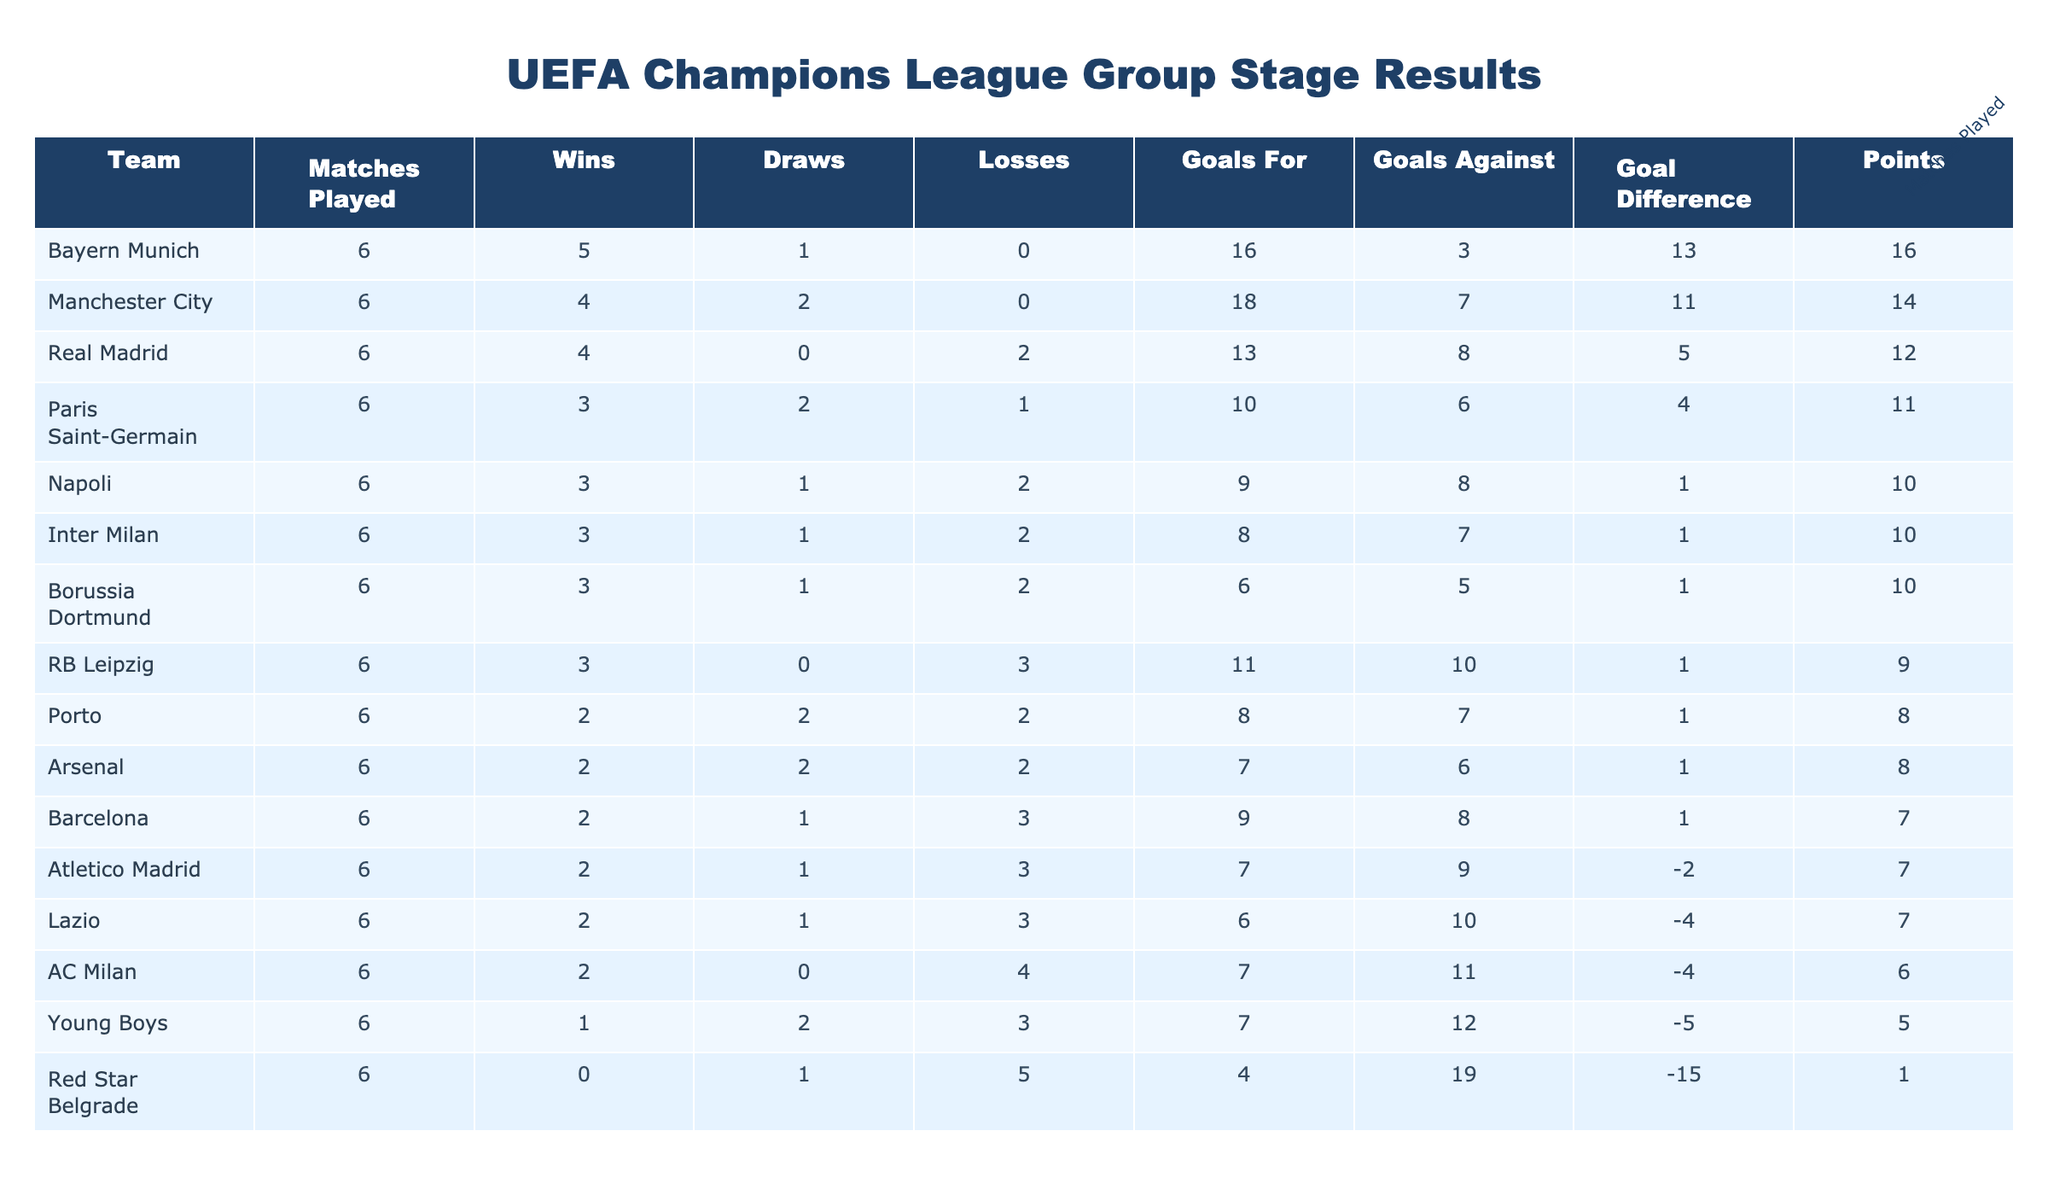What team has the highest number of points? Bayern Munich has the highest points with a total of 16. This is clear from the "Points" column, where Bayern Munich is at the top.
Answer: Bayern Munich How many goals did Manchester City score during the group stage? According to the "Goals For" column, Manchester City scored 18 goals in the group stage.
Answer: 18 Which team had the worst goal difference? Red Star Belgrade had the worst goal difference of -15, as shown in the "Goal Difference" column, which is the lowest value in the table.
Answer: Red Star Belgrade How many teams finished with the same number of points as Lazio? Lazio finished with 7 points, and three other teams (Barcelona, Atletico Madrid, and AC Milan) also had 7 points. Therefore, four teams have the same points as Lazio.
Answer: 3 What is the total number of wins for teams from the table? By adding all the wins in the "Wins" column (5+4+4+3+3+3+3+2+2+2+2+2+2+1+0) we find the total wins are 36.
Answer: 36 What percentage of matches did Paris Saint-Germain win? Paris Saint-Germain won 3 out of 6 matches. To find the percentage, divide the number of wins (3) by matches played (6) and multiply by 100: (3/6)*100 = 50%.
Answer: 50% Did any team finish without any wins? Yes, Red Star Belgrade finished without any wins, as they have 0 in the "Wins" column.
Answer: Yes Which team had the highest goals against? Red Star Belgrade had the highest goals against, with 19 goals conceded, as indicated in the "Goals Against" column.
Answer: Red Star Belgrade What is the average number of goals scored by teams that won at least 3 matches? First, identify teams with 3 or more wins: Bayern Munich (16), Manchester City (18), Real Madrid (13), PSG (10), Napoli (9), Inter Milan (8), Dortmund (6), and RB Leipzig (11). The total goals are 16+18+13+10+9+8+6+11 = 93. There are 8 teams, so the average is 93/8 = 11.625.
Answer: 11.625 How many teams achieved a positive goal difference? There are 8 teams with a positive goal difference: Bayern Munich (13), Manchester City (11), Real Madrid (5), PSG (4), Napoli (1), Inter Milan (1), Borussia Dortmund (1), and RB Leipzig (1). Therefore, the total number of teams with a positive goal difference is 8.
Answer: 8 